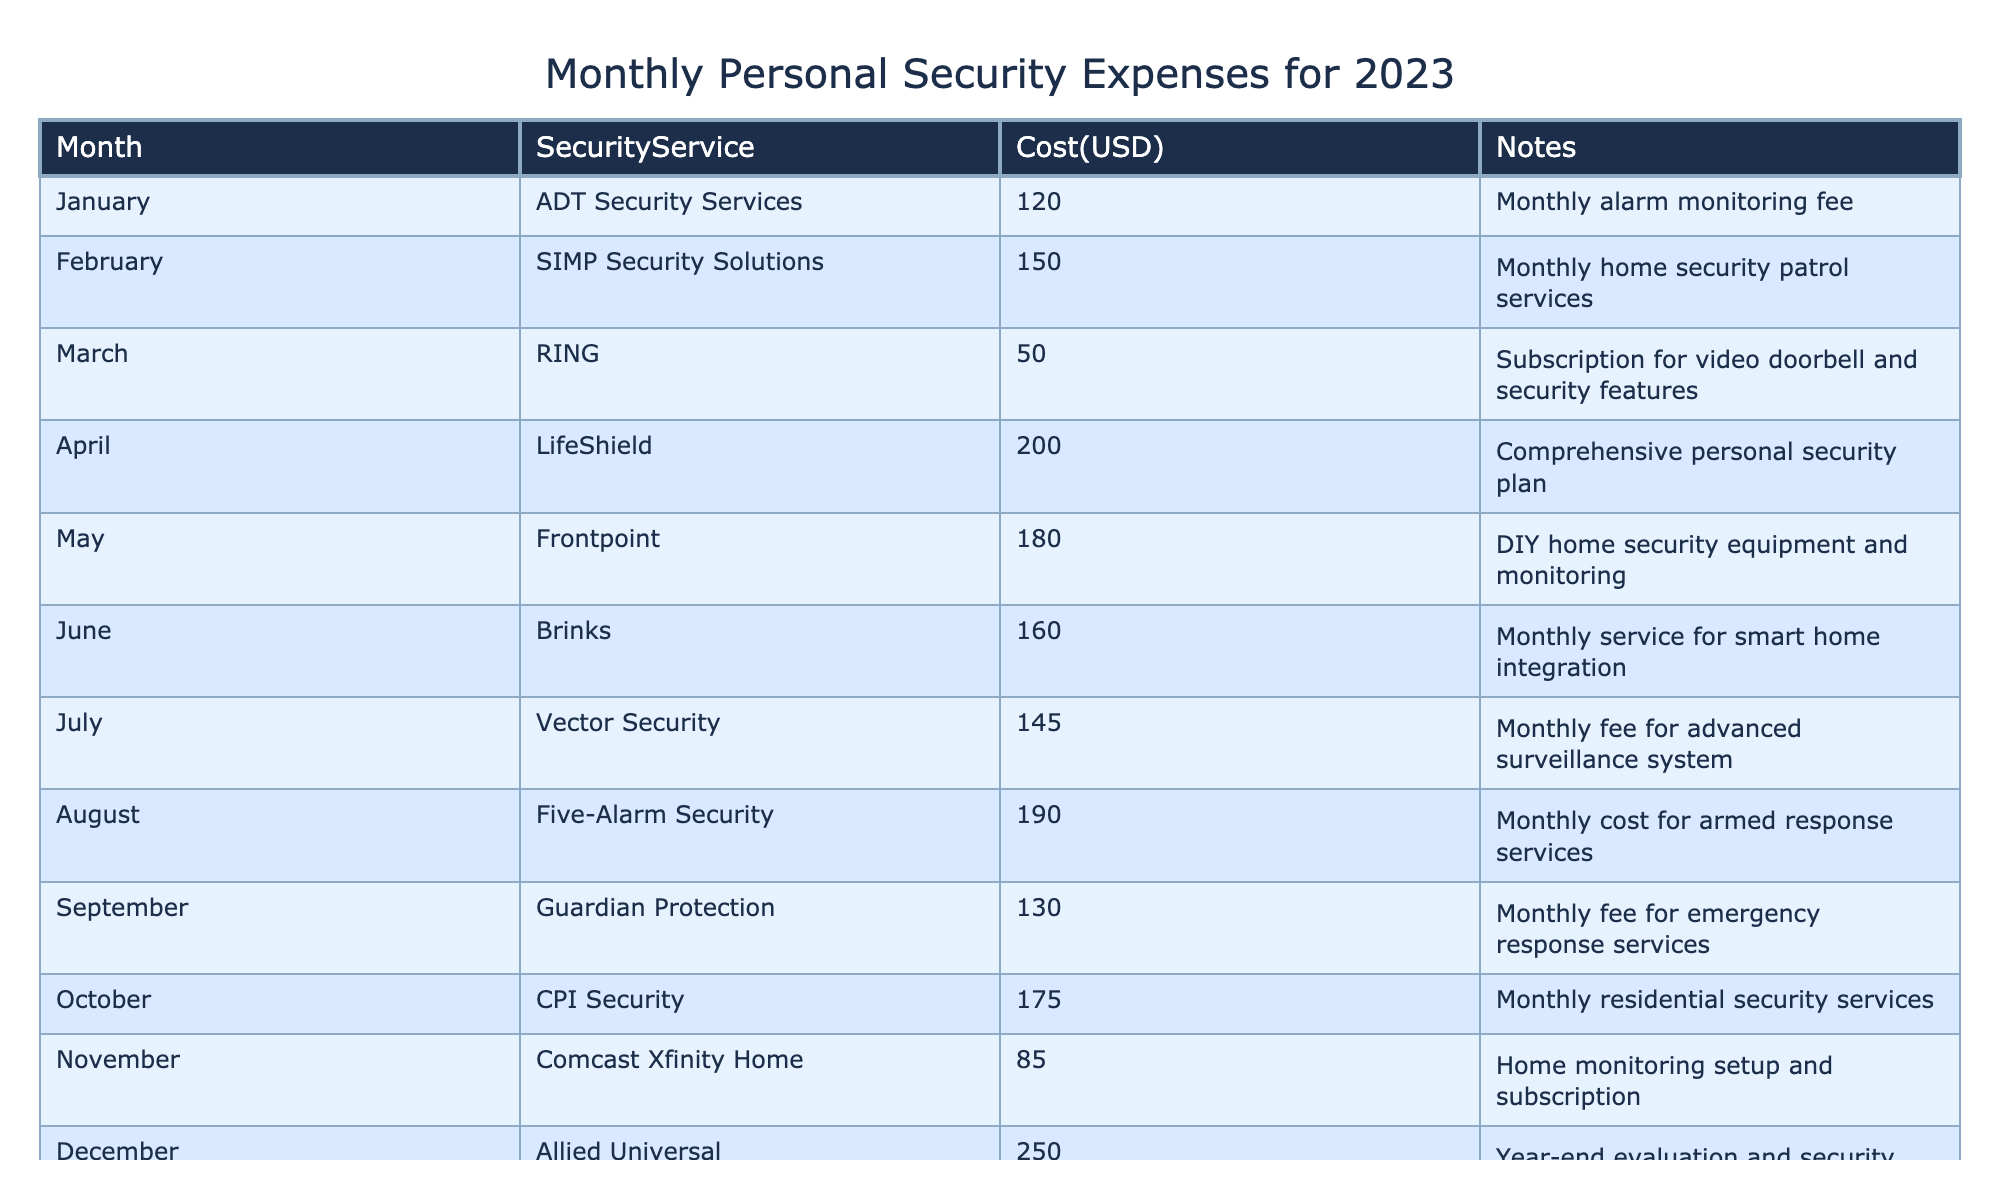What was the cost of the most expensive security service in December? The table shows that the cost of Allied Universal's services in December is 250. This is the highest value in the 'Cost(USD)' column.
Answer: 250 Which month had the lowest security expenses? By looking at the 'Cost(USD)' column, I can see that the lowest expense is in March with a cost of 50 for RING.
Answer: 50 How much did I spend on security services in total for the year? To find the total, sum up all the values in the 'Cost(USD)' column: 120 + 150 + 50 + 200 + 180 + 160 + 145 + 190 + 130 + 175 + 85 + 250 = 1,680.
Answer: 1680 Was the monthly expense for home security patrol services in February higher than the average monthly expense for the entire year? The total expense for the year is 1,680. There are 12 months, so the average expense is 1,680 / 12 = 140. The expense for February is 150, which is higher than the average of 140.
Answer: Yes How much more did I spend on services in August compared to June? The cost in August is 190, while the cost in June is 160. The difference is 190 - 160 = 30.
Answer: 30 What percentage of the total yearly expense did the armed response services in August account for? The cost for August is 190. The total yearly expense is 1,680. To find the percentage, calculate (190 / 1,680) * 100 = 11.3%.
Answer: 11.3% Which service offered the lowest monthly cost, and what was that cost? The table lists the lowest cost as 50 for RING in March, which is the lowest entry in the 'Cost(USD)' column.
Answer: RING, 50 Did I incur any expenses for home monitoring services in November? The table indicates that in November, I spent 85 for Comcast Xfinity Home, which is indeed a home monitoring service.
Answer: Yes What was the average cost of security services for the last quarter (October to December)? In the last quarter, the costs are 175 (October), 85 (November), and 250 (December). The average is (175 + 85 + 250) / 3 = 170.
Answer: 170 Which month had the highest cost for security services and what was the cost? The highest cost in the table is 250 for Allied Universal in December.
Answer: December, 250 